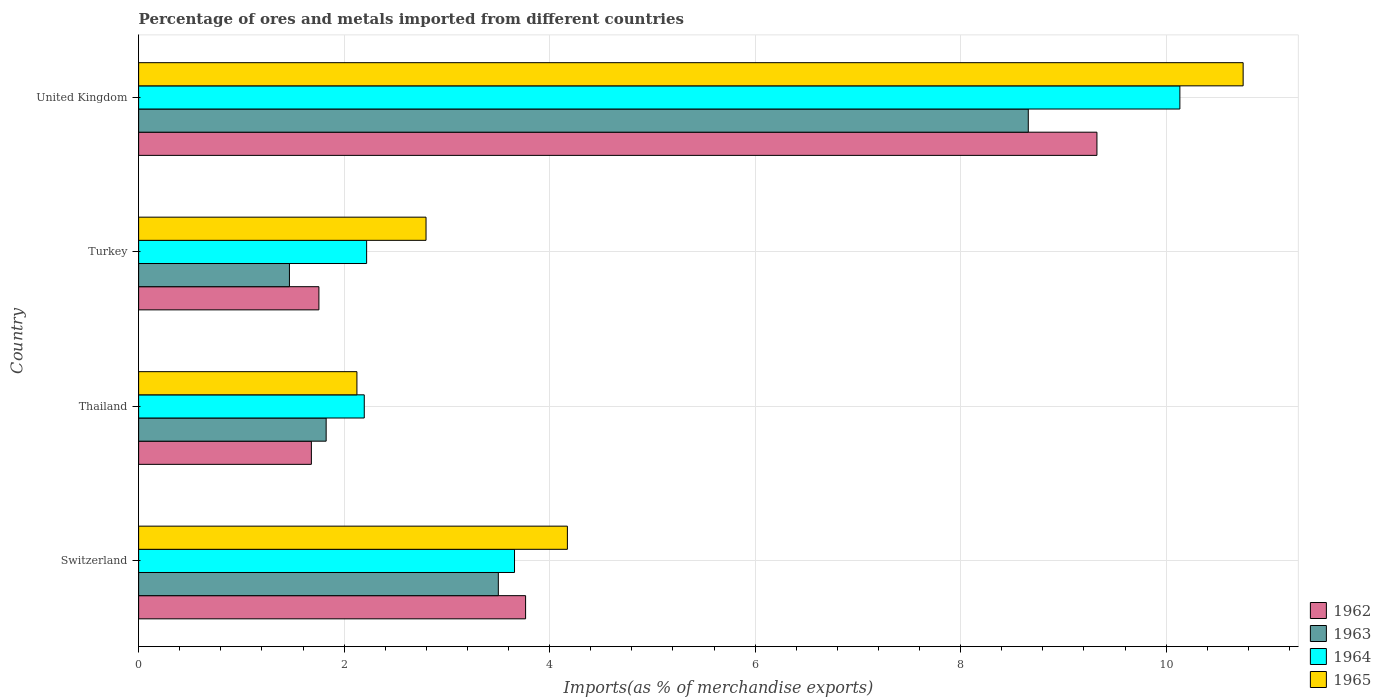How many groups of bars are there?
Your answer should be very brief. 4. Are the number of bars per tick equal to the number of legend labels?
Your answer should be compact. Yes. Are the number of bars on each tick of the Y-axis equal?
Your answer should be compact. Yes. How many bars are there on the 2nd tick from the bottom?
Keep it short and to the point. 4. What is the label of the 4th group of bars from the top?
Ensure brevity in your answer.  Switzerland. What is the percentage of imports to different countries in 1962 in Switzerland?
Your answer should be compact. 3.77. Across all countries, what is the maximum percentage of imports to different countries in 1963?
Give a very brief answer. 8.66. Across all countries, what is the minimum percentage of imports to different countries in 1962?
Give a very brief answer. 1.68. In which country was the percentage of imports to different countries in 1962 maximum?
Your response must be concise. United Kingdom. In which country was the percentage of imports to different countries in 1962 minimum?
Your response must be concise. Thailand. What is the total percentage of imports to different countries in 1963 in the graph?
Your answer should be very brief. 15.45. What is the difference between the percentage of imports to different countries in 1963 in Thailand and that in United Kingdom?
Provide a short and direct response. -6.83. What is the difference between the percentage of imports to different countries in 1965 in Switzerland and the percentage of imports to different countries in 1962 in Thailand?
Provide a short and direct response. 2.49. What is the average percentage of imports to different countries in 1965 per country?
Provide a succinct answer. 4.96. What is the difference between the percentage of imports to different countries in 1965 and percentage of imports to different countries in 1963 in Thailand?
Your response must be concise. 0.3. In how many countries, is the percentage of imports to different countries in 1965 greater than 1.2000000000000002 %?
Offer a terse response. 4. What is the ratio of the percentage of imports to different countries in 1964 in Switzerland to that in Thailand?
Provide a short and direct response. 1.67. Is the percentage of imports to different countries in 1963 in Switzerland less than that in Turkey?
Your answer should be compact. No. Is the difference between the percentage of imports to different countries in 1965 in Thailand and Turkey greater than the difference between the percentage of imports to different countries in 1963 in Thailand and Turkey?
Provide a succinct answer. No. What is the difference between the highest and the second highest percentage of imports to different countries in 1965?
Make the answer very short. 6.58. What is the difference between the highest and the lowest percentage of imports to different countries in 1962?
Make the answer very short. 7.65. In how many countries, is the percentage of imports to different countries in 1963 greater than the average percentage of imports to different countries in 1963 taken over all countries?
Keep it short and to the point. 1. What does the 1st bar from the top in United Kingdom represents?
Make the answer very short. 1965. What does the 1st bar from the bottom in United Kingdom represents?
Your response must be concise. 1962. Are all the bars in the graph horizontal?
Give a very brief answer. Yes. How many countries are there in the graph?
Your answer should be very brief. 4. Does the graph contain grids?
Provide a short and direct response. Yes. Where does the legend appear in the graph?
Give a very brief answer. Bottom right. How are the legend labels stacked?
Give a very brief answer. Vertical. What is the title of the graph?
Offer a very short reply. Percentage of ores and metals imported from different countries. What is the label or title of the X-axis?
Your answer should be compact. Imports(as % of merchandise exports). What is the label or title of the Y-axis?
Make the answer very short. Country. What is the Imports(as % of merchandise exports) of 1962 in Switzerland?
Give a very brief answer. 3.77. What is the Imports(as % of merchandise exports) of 1963 in Switzerland?
Your response must be concise. 3.5. What is the Imports(as % of merchandise exports) of 1964 in Switzerland?
Offer a very short reply. 3.66. What is the Imports(as % of merchandise exports) in 1965 in Switzerland?
Offer a terse response. 4.17. What is the Imports(as % of merchandise exports) in 1962 in Thailand?
Make the answer very short. 1.68. What is the Imports(as % of merchandise exports) of 1963 in Thailand?
Your answer should be compact. 1.83. What is the Imports(as % of merchandise exports) of 1964 in Thailand?
Offer a very short reply. 2.2. What is the Imports(as % of merchandise exports) of 1965 in Thailand?
Ensure brevity in your answer.  2.12. What is the Imports(as % of merchandise exports) in 1962 in Turkey?
Ensure brevity in your answer.  1.75. What is the Imports(as % of merchandise exports) of 1963 in Turkey?
Provide a succinct answer. 1.47. What is the Imports(as % of merchandise exports) of 1964 in Turkey?
Give a very brief answer. 2.22. What is the Imports(as % of merchandise exports) in 1965 in Turkey?
Your answer should be compact. 2.8. What is the Imports(as % of merchandise exports) of 1962 in United Kingdom?
Offer a very short reply. 9.33. What is the Imports(as % of merchandise exports) in 1963 in United Kingdom?
Offer a very short reply. 8.66. What is the Imports(as % of merchandise exports) in 1964 in United Kingdom?
Offer a terse response. 10.13. What is the Imports(as % of merchandise exports) in 1965 in United Kingdom?
Your response must be concise. 10.75. Across all countries, what is the maximum Imports(as % of merchandise exports) of 1962?
Your response must be concise. 9.33. Across all countries, what is the maximum Imports(as % of merchandise exports) of 1963?
Provide a succinct answer. 8.66. Across all countries, what is the maximum Imports(as % of merchandise exports) of 1964?
Offer a terse response. 10.13. Across all countries, what is the maximum Imports(as % of merchandise exports) of 1965?
Give a very brief answer. 10.75. Across all countries, what is the minimum Imports(as % of merchandise exports) of 1962?
Your answer should be compact. 1.68. Across all countries, what is the minimum Imports(as % of merchandise exports) in 1963?
Your response must be concise. 1.47. Across all countries, what is the minimum Imports(as % of merchandise exports) of 1964?
Give a very brief answer. 2.2. Across all countries, what is the minimum Imports(as % of merchandise exports) of 1965?
Your answer should be compact. 2.12. What is the total Imports(as % of merchandise exports) in 1962 in the graph?
Your answer should be compact. 16.53. What is the total Imports(as % of merchandise exports) of 1963 in the graph?
Your response must be concise. 15.45. What is the total Imports(as % of merchandise exports) in 1964 in the graph?
Provide a succinct answer. 18.21. What is the total Imports(as % of merchandise exports) of 1965 in the graph?
Provide a short and direct response. 19.84. What is the difference between the Imports(as % of merchandise exports) in 1962 in Switzerland and that in Thailand?
Give a very brief answer. 2.08. What is the difference between the Imports(as % of merchandise exports) of 1963 in Switzerland and that in Thailand?
Give a very brief answer. 1.68. What is the difference between the Imports(as % of merchandise exports) of 1964 in Switzerland and that in Thailand?
Provide a short and direct response. 1.46. What is the difference between the Imports(as % of merchandise exports) in 1965 in Switzerland and that in Thailand?
Provide a succinct answer. 2.05. What is the difference between the Imports(as % of merchandise exports) of 1962 in Switzerland and that in Turkey?
Keep it short and to the point. 2.01. What is the difference between the Imports(as % of merchandise exports) of 1963 in Switzerland and that in Turkey?
Provide a succinct answer. 2.03. What is the difference between the Imports(as % of merchandise exports) of 1964 in Switzerland and that in Turkey?
Your response must be concise. 1.44. What is the difference between the Imports(as % of merchandise exports) in 1965 in Switzerland and that in Turkey?
Your answer should be compact. 1.38. What is the difference between the Imports(as % of merchandise exports) in 1962 in Switzerland and that in United Kingdom?
Provide a short and direct response. -5.56. What is the difference between the Imports(as % of merchandise exports) of 1963 in Switzerland and that in United Kingdom?
Offer a terse response. -5.16. What is the difference between the Imports(as % of merchandise exports) of 1964 in Switzerland and that in United Kingdom?
Your response must be concise. -6.48. What is the difference between the Imports(as % of merchandise exports) in 1965 in Switzerland and that in United Kingdom?
Offer a terse response. -6.58. What is the difference between the Imports(as % of merchandise exports) in 1962 in Thailand and that in Turkey?
Give a very brief answer. -0.07. What is the difference between the Imports(as % of merchandise exports) of 1963 in Thailand and that in Turkey?
Give a very brief answer. 0.36. What is the difference between the Imports(as % of merchandise exports) of 1964 in Thailand and that in Turkey?
Make the answer very short. -0.02. What is the difference between the Imports(as % of merchandise exports) in 1965 in Thailand and that in Turkey?
Provide a short and direct response. -0.67. What is the difference between the Imports(as % of merchandise exports) in 1962 in Thailand and that in United Kingdom?
Your response must be concise. -7.65. What is the difference between the Imports(as % of merchandise exports) in 1963 in Thailand and that in United Kingdom?
Give a very brief answer. -6.83. What is the difference between the Imports(as % of merchandise exports) of 1964 in Thailand and that in United Kingdom?
Offer a very short reply. -7.94. What is the difference between the Imports(as % of merchandise exports) in 1965 in Thailand and that in United Kingdom?
Keep it short and to the point. -8.62. What is the difference between the Imports(as % of merchandise exports) of 1962 in Turkey and that in United Kingdom?
Make the answer very short. -7.57. What is the difference between the Imports(as % of merchandise exports) of 1963 in Turkey and that in United Kingdom?
Make the answer very short. -7.19. What is the difference between the Imports(as % of merchandise exports) of 1964 in Turkey and that in United Kingdom?
Offer a terse response. -7.91. What is the difference between the Imports(as % of merchandise exports) of 1965 in Turkey and that in United Kingdom?
Ensure brevity in your answer.  -7.95. What is the difference between the Imports(as % of merchandise exports) in 1962 in Switzerland and the Imports(as % of merchandise exports) in 1963 in Thailand?
Your response must be concise. 1.94. What is the difference between the Imports(as % of merchandise exports) in 1962 in Switzerland and the Imports(as % of merchandise exports) in 1964 in Thailand?
Your answer should be very brief. 1.57. What is the difference between the Imports(as % of merchandise exports) of 1962 in Switzerland and the Imports(as % of merchandise exports) of 1965 in Thailand?
Provide a short and direct response. 1.64. What is the difference between the Imports(as % of merchandise exports) of 1963 in Switzerland and the Imports(as % of merchandise exports) of 1964 in Thailand?
Provide a succinct answer. 1.3. What is the difference between the Imports(as % of merchandise exports) in 1963 in Switzerland and the Imports(as % of merchandise exports) in 1965 in Thailand?
Your answer should be very brief. 1.38. What is the difference between the Imports(as % of merchandise exports) of 1964 in Switzerland and the Imports(as % of merchandise exports) of 1965 in Thailand?
Ensure brevity in your answer.  1.53. What is the difference between the Imports(as % of merchandise exports) in 1962 in Switzerland and the Imports(as % of merchandise exports) in 1963 in Turkey?
Your answer should be compact. 2.3. What is the difference between the Imports(as % of merchandise exports) in 1962 in Switzerland and the Imports(as % of merchandise exports) in 1964 in Turkey?
Offer a very short reply. 1.55. What is the difference between the Imports(as % of merchandise exports) in 1962 in Switzerland and the Imports(as % of merchandise exports) in 1965 in Turkey?
Provide a short and direct response. 0.97. What is the difference between the Imports(as % of merchandise exports) in 1963 in Switzerland and the Imports(as % of merchandise exports) in 1964 in Turkey?
Your response must be concise. 1.28. What is the difference between the Imports(as % of merchandise exports) of 1963 in Switzerland and the Imports(as % of merchandise exports) of 1965 in Turkey?
Provide a succinct answer. 0.7. What is the difference between the Imports(as % of merchandise exports) in 1964 in Switzerland and the Imports(as % of merchandise exports) in 1965 in Turkey?
Your answer should be very brief. 0.86. What is the difference between the Imports(as % of merchandise exports) in 1962 in Switzerland and the Imports(as % of merchandise exports) in 1963 in United Kingdom?
Make the answer very short. -4.89. What is the difference between the Imports(as % of merchandise exports) in 1962 in Switzerland and the Imports(as % of merchandise exports) in 1964 in United Kingdom?
Provide a short and direct response. -6.37. What is the difference between the Imports(as % of merchandise exports) of 1962 in Switzerland and the Imports(as % of merchandise exports) of 1965 in United Kingdom?
Offer a terse response. -6.98. What is the difference between the Imports(as % of merchandise exports) in 1963 in Switzerland and the Imports(as % of merchandise exports) in 1964 in United Kingdom?
Offer a very short reply. -6.63. What is the difference between the Imports(as % of merchandise exports) in 1963 in Switzerland and the Imports(as % of merchandise exports) in 1965 in United Kingdom?
Keep it short and to the point. -7.25. What is the difference between the Imports(as % of merchandise exports) of 1964 in Switzerland and the Imports(as % of merchandise exports) of 1965 in United Kingdom?
Ensure brevity in your answer.  -7.09. What is the difference between the Imports(as % of merchandise exports) in 1962 in Thailand and the Imports(as % of merchandise exports) in 1963 in Turkey?
Make the answer very short. 0.21. What is the difference between the Imports(as % of merchandise exports) of 1962 in Thailand and the Imports(as % of merchandise exports) of 1964 in Turkey?
Your answer should be compact. -0.54. What is the difference between the Imports(as % of merchandise exports) in 1962 in Thailand and the Imports(as % of merchandise exports) in 1965 in Turkey?
Offer a very short reply. -1.12. What is the difference between the Imports(as % of merchandise exports) in 1963 in Thailand and the Imports(as % of merchandise exports) in 1964 in Turkey?
Offer a terse response. -0.39. What is the difference between the Imports(as % of merchandise exports) of 1963 in Thailand and the Imports(as % of merchandise exports) of 1965 in Turkey?
Your response must be concise. -0.97. What is the difference between the Imports(as % of merchandise exports) in 1964 in Thailand and the Imports(as % of merchandise exports) in 1965 in Turkey?
Make the answer very short. -0.6. What is the difference between the Imports(as % of merchandise exports) of 1962 in Thailand and the Imports(as % of merchandise exports) of 1963 in United Kingdom?
Offer a terse response. -6.98. What is the difference between the Imports(as % of merchandise exports) in 1962 in Thailand and the Imports(as % of merchandise exports) in 1964 in United Kingdom?
Give a very brief answer. -8.45. What is the difference between the Imports(as % of merchandise exports) in 1962 in Thailand and the Imports(as % of merchandise exports) in 1965 in United Kingdom?
Ensure brevity in your answer.  -9.07. What is the difference between the Imports(as % of merchandise exports) of 1963 in Thailand and the Imports(as % of merchandise exports) of 1964 in United Kingdom?
Offer a very short reply. -8.31. What is the difference between the Imports(as % of merchandise exports) of 1963 in Thailand and the Imports(as % of merchandise exports) of 1965 in United Kingdom?
Offer a terse response. -8.92. What is the difference between the Imports(as % of merchandise exports) of 1964 in Thailand and the Imports(as % of merchandise exports) of 1965 in United Kingdom?
Offer a very short reply. -8.55. What is the difference between the Imports(as % of merchandise exports) in 1962 in Turkey and the Imports(as % of merchandise exports) in 1963 in United Kingdom?
Give a very brief answer. -6.9. What is the difference between the Imports(as % of merchandise exports) of 1962 in Turkey and the Imports(as % of merchandise exports) of 1964 in United Kingdom?
Your response must be concise. -8.38. What is the difference between the Imports(as % of merchandise exports) in 1962 in Turkey and the Imports(as % of merchandise exports) in 1965 in United Kingdom?
Give a very brief answer. -8.99. What is the difference between the Imports(as % of merchandise exports) of 1963 in Turkey and the Imports(as % of merchandise exports) of 1964 in United Kingdom?
Offer a very short reply. -8.67. What is the difference between the Imports(as % of merchandise exports) in 1963 in Turkey and the Imports(as % of merchandise exports) in 1965 in United Kingdom?
Provide a succinct answer. -9.28. What is the difference between the Imports(as % of merchandise exports) in 1964 in Turkey and the Imports(as % of merchandise exports) in 1965 in United Kingdom?
Offer a very short reply. -8.53. What is the average Imports(as % of merchandise exports) of 1962 per country?
Ensure brevity in your answer.  4.13. What is the average Imports(as % of merchandise exports) of 1963 per country?
Provide a succinct answer. 3.86. What is the average Imports(as % of merchandise exports) in 1964 per country?
Ensure brevity in your answer.  4.55. What is the average Imports(as % of merchandise exports) in 1965 per country?
Provide a short and direct response. 4.96. What is the difference between the Imports(as % of merchandise exports) in 1962 and Imports(as % of merchandise exports) in 1963 in Switzerland?
Your answer should be compact. 0.27. What is the difference between the Imports(as % of merchandise exports) of 1962 and Imports(as % of merchandise exports) of 1964 in Switzerland?
Your answer should be compact. 0.11. What is the difference between the Imports(as % of merchandise exports) in 1962 and Imports(as % of merchandise exports) in 1965 in Switzerland?
Offer a terse response. -0.41. What is the difference between the Imports(as % of merchandise exports) in 1963 and Imports(as % of merchandise exports) in 1964 in Switzerland?
Offer a very short reply. -0.16. What is the difference between the Imports(as % of merchandise exports) in 1963 and Imports(as % of merchandise exports) in 1965 in Switzerland?
Provide a succinct answer. -0.67. What is the difference between the Imports(as % of merchandise exports) in 1964 and Imports(as % of merchandise exports) in 1965 in Switzerland?
Your answer should be compact. -0.51. What is the difference between the Imports(as % of merchandise exports) of 1962 and Imports(as % of merchandise exports) of 1963 in Thailand?
Give a very brief answer. -0.14. What is the difference between the Imports(as % of merchandise exports) in 1962 and Imports(as % of merchandise exports) in 1964 in Thailand?
Make the answer very short. -0.51. What is the difference between the Imports(as % of merchandise exports) of 1962 and Imports(as % of merchandise exports) of 1965 in Thailand?
Provide a short and direct response. -0.44. What is the difference between the Imports(as % of merchandise exports) in 1963 and Imports(as % of merchandise exports) in 1964 in Thailand?
Make the answer very short. -0.37. What is the difference between the Imports(as % of merchandise exports) in 1963 and Imports(as % of merchandise exports) in 1965 in Thailand?
Provide a short and direct response. -0.3. What is the difference between the Imports(as % of merchandise exports) in 1964 and Imports(as % of merchandise exports) in 1965 in Thailand?
Provide a succinct answer. 0.07. What is the difference between the Imports(as % of merchandise exports) in 1962 and Imports(as % of merchandise exports) in 1963 in Turkey?
Offer a terse response. 0.29. What is the difference between the Imports(as % of merchandise exports) of 1962 and Imports(as % of merchandise exports) of 1964 in Turkey?
Offer a terse response. -0.46. What is the difference between the Imports(as % of merchandise exports) in 1962 and Imports(as % of merchandise exports) in 1965 in Turkey?
Offer a very short reply. -1.04. What is the difference between the Imports(as % of merchandise exports) of 1963 and Imports(as % of merchandise exports) of 1964 in Turkey?
Give a very brief answer. -0.75. What is the difference between the Imports(as % of merchandise exports) of 1963 and Imports(as % of merchandise exports) of 1965 in Turkey?
Offer a terse response. -1.33. What is the difference between the Imports(as % of merchandise exports) in 1964 and Imports(as % of merchandise exports) in 1965 in Turkey?
Offer a terse response. -0.58. What is the difference between the Imports(as % of merchandise exports) of 1962 and Imports(as % of merchandise exports) of 1963 in United Kingdom?
Make the answer very short. 0.67. What is the difference between the Imports(as % of merchandise exports) in 1962 and Imports(as % of merchandise exports) in 1964 in United Kingdom?
Ensure brevity in your answer.  -0.81. What is the difference between the Imports(as % of merchandise exports) in 1962 and Imports(as % of merchandise exports) in 1965 in United Kingdom?
Keep it short and to the point. -1.42. What is the difference between the Imports(as % of merchandise exports) of 1963 and Imports(as % of merchandise exports) of 1964 in United Kingdom?
Offer a very short reply. -1.48. What is the difference between the Imports(as % of merchandise exports) of 1963 and Imports(as % of merchandise exports) of 1965 in United Kingdom?
Offer a very short reply. -2.09. What is the difference between the Imports(as % of merchandise exports) of 1964 and Imports(as % of merchandise exports) of 1965 in United Kingdom?
Your answer should be very brief. -0.62. What is the ratio of the Imports(as % of merchandise exports) in 1962 in Switzerland to that in Thailand?
Offer a very short reply. 2.24. What is the ratio of the Imports(as % of merchandise exports) in 1963 in Switzerland to that in Thailand?
Offer a very short reply. 1.92. What is the ratio of the Imports(as % of merchandise exports) of 1964 in Switzerland to that in Thailand?
Offer a terse response. 1.67. What is the ratio of the Imports(as % of merchandise exports) of 1965 in Switzerland to that in Thailand?
Your response must be concise. 1.96. What is the ratio of the Imports(as % of merchandise exports) in 1962 in Switzerland to that in Turkey?
Keep it short and to the point. 2.15. What is the ratio of the Imports(as % of merchandise exports) of 1963 in Switzerland to that in Turkey?
Provide a short and direct response. 2.38. What is the ratio of the Imports(as % of merchandise exports) of 1964 in Switzerland to that in Turkey?
Provide a short and direct response. 1.65. What is the ratio of the Imports(as % of merchandise exports) in 1965 in Switzerland to that in Turkey?
Your response must be concise. 1.49. What is the ratio of the Imports(as % of merchandise exports) in 1962 in Switzerland to that in United Kingdom?
Provide a succinct answer. 0.4. What is the ratio of the Imports(as % of merchandise exports) in 1963 in Switzerland to that in United Kingdom?
Your response must be concise. 0.4. What is the ratio of the Imports(as % of merchandise exports) of 1964 in Switzerland to that in United Kingdom?
Your answer should be compact. 0.36. What is the ratio of the Imports(as % of merchandise exports) in 1965 in Switzerland to that in United Kingdom?
Give a very brief answer. 0.39. What is the ratio of the Imports(as % of merchandise exports) of 1962 in Thailand to that in Turkey?
Offer a very short reply. 0.96. What is the ratio of the Imports(as % of merchandise exports) of 1963 in Thailand to that in Turkey?
Offer a terse response. 1.24. What is the ratio of the Imports(as % of merchandise exports) of 1964 in Thailand to that in Turkey?
Your answer should be very brief. 0.99. What is the ratio of the Imports(as % of merchandise exports) of 1965 in Thailand to that in Turkey?
Offer a very short reply. 0.76. What is the ratio of the Imports(as % of merchandise exports) in 1962 in Thailand to that in United Kingdom?
Give a very brief answer. 0.18. What is the ratio of the Imports(as % of merchandise exports) of 1963 in Thailand to that in United Kingdom?
Provide a succinct answer. 0.21. What is the ratio of the Imports(as % of merchandise exports) of 1964 in Thailand to that in United Kingdom?
Offer a terse response. 0.22. What is the ratio of the Imports(as % of merchandise exports) of 1965 in Thailand to that in United Kingdom?
Keep it short and to the point. 0.2. What is the ratio of the Imports(as % of merchandise exports) in 1962 in Turkey to that in United Kingdom?
Provide a succinct answer. 0.19. What is the ratio of the Imports(as % of merchandise exports) in 1963 in Turkey to that in United Kingdom?
Your response must be concise. 0.17. What is the ratio of the Imports(as % of merchandise exports) in 1964 in Turkey to that in United Kingdom?
Ensure brevity in your answer.  0.22. What is the ratio of the Imports(as % of merchandise exports) in 1965 in Turkey to that in United Kingdom?
Your answer should be very brief. 0.26. What is the difference between the highest and the second highest Imports(as % of merchandise exports) in 1962?
Make the answer very short. 5.56. What is the difference between the highest and the second highest Imports(as % of merchandise exports) of 1963?
Give a very brief answer. 5.16. What is the difference between the highest and the second highest Imports(as % of merchandise exports) in 1964?
Your answer should be very brief. 6.48. What is the difference between the highest and the second highest Imports(as % of merchandise exports) in 1965?
Keep it short and to the point. 6.58. What is the difference between the highest and the lowest Imports(as % of merchandise exports) in 1962?
Provide a succinct answer. 7.65. What is the difference between the highest and the lowest Imports(as % of merchandise exports) of 1963?
Ensure brevity in your answer.  7.19. What is the difference between the highest and the lowest Imports(as % of merchandise exports) in 1964?
Offer a very short reply. 7.94. What is the difference between the highest and the lowest Imports(as % of merchandise exports) of 1965?
Give a very brief answer. 8.62. 